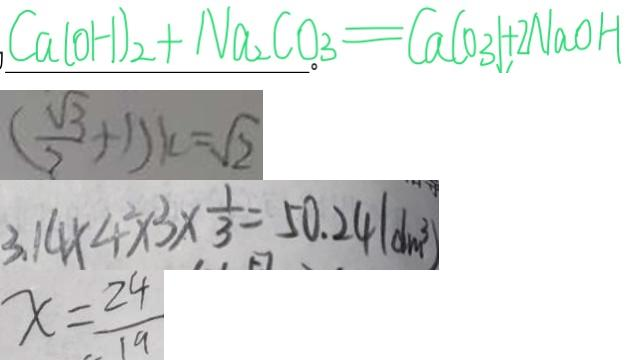Convert formula to latex. <formula><loc_0><loc_0><loc_500><loc_500>C a ( O H ) _ { 2 } + N a _ { 2 } C O _ { 3 } = C a C O _ { 3 } \downarrow + 2 N a O H 
 ( \frac { \sqrt { 3 } } { 2 } + 1 ) k = \sqrt { 2 } 
 3 . 1 4 \times 4 \times 3 \times \frac { 1 } { 3 } = 5 0 . 2 4 ( d m ^ { 3 } ) 
 x = \frac { 2 4 } { 1 9 }</formula> 